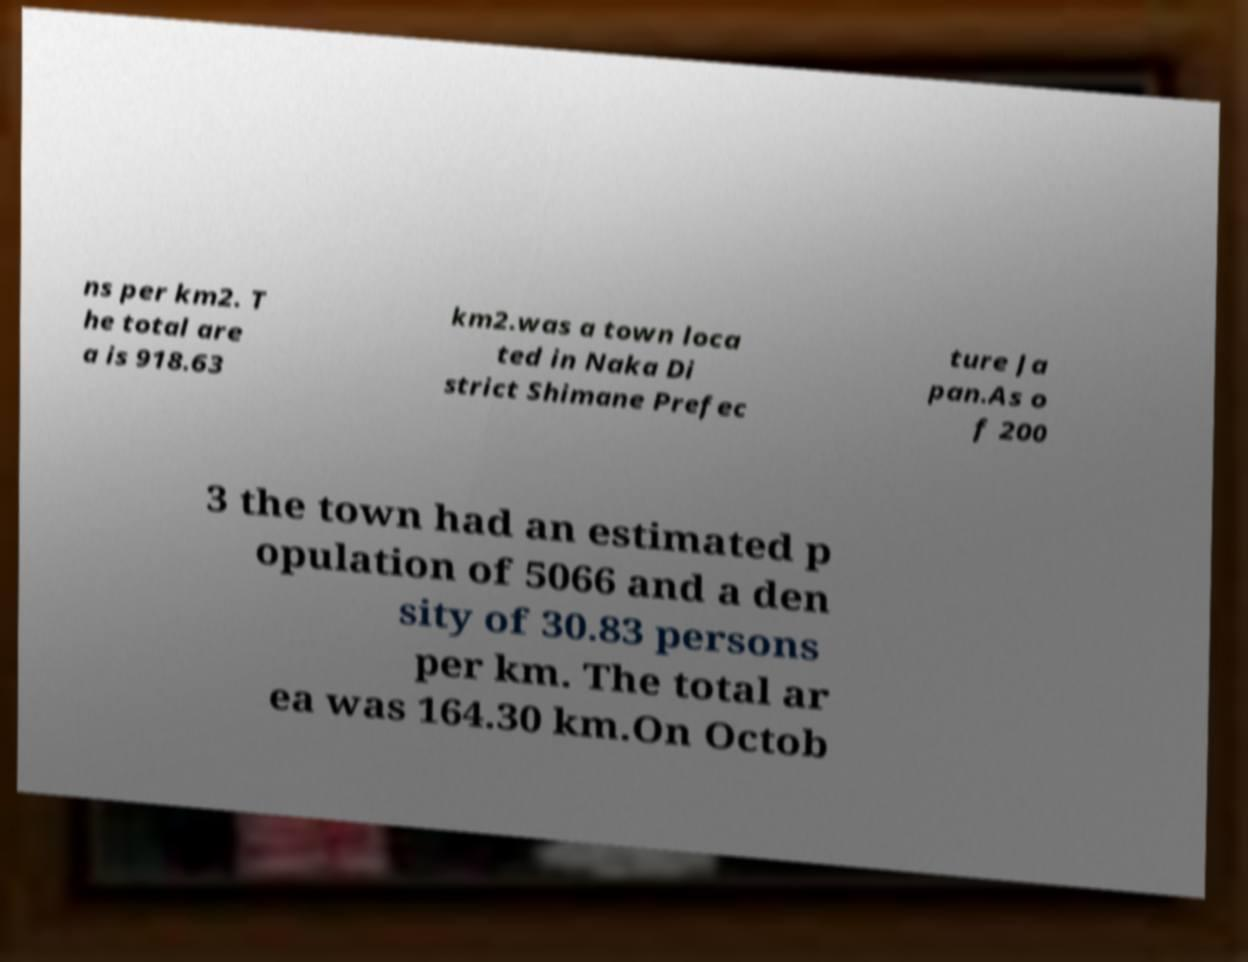What messages or text are displayed in this image? I need them in a readable, typed format. ns per km2. T he total are a is 918.63 km2.was a town loca ted in Naka Di strict Shimane Prefec ture Ja pan.As o f 200 3 the town had an estimated p opulation of 5066 and a den sity of 30.83 persons per km. The total ar ea was 164.30 km.On Octob 